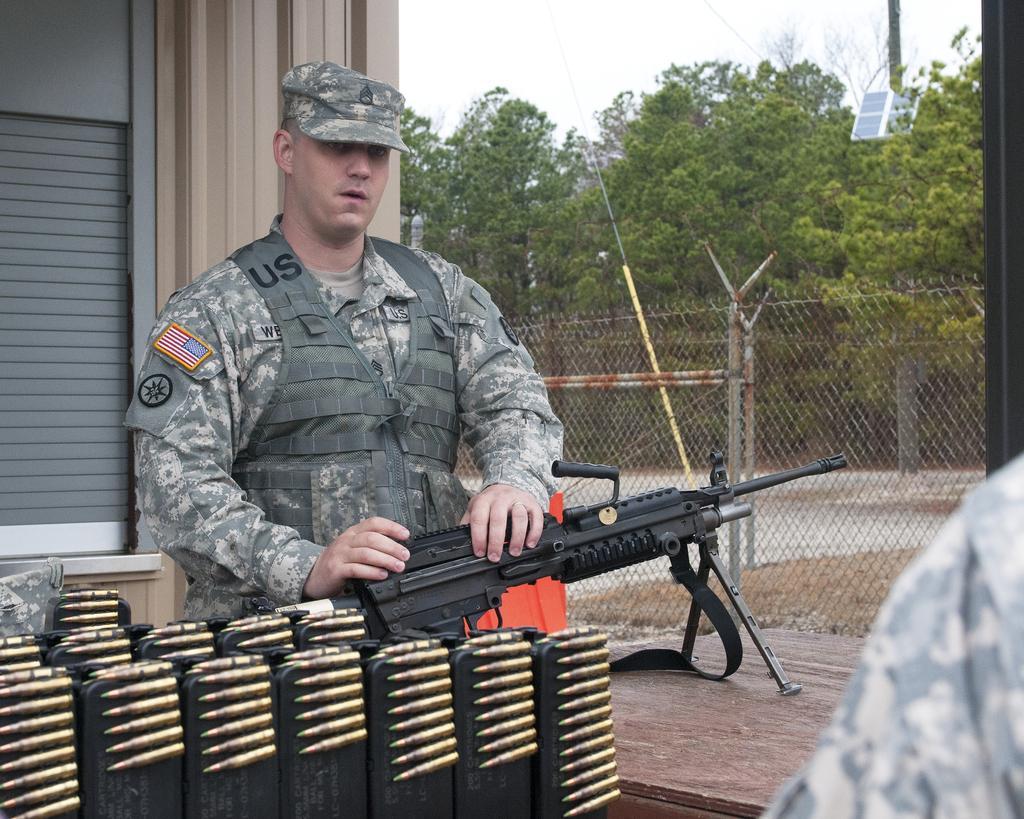In one or two sentences, can you explain what this image depicts? In this image there is the sky towards the top of the image, there is a solar panel, there are trees, there is a wire, there is a fence, there are poles, there is an object towards the right of the image, there are objects towards the bottom of the image, there is a gun on the wooden surface, there is a man standing, there is a person towards the right of the image, there is a wall towards the left of the image. 